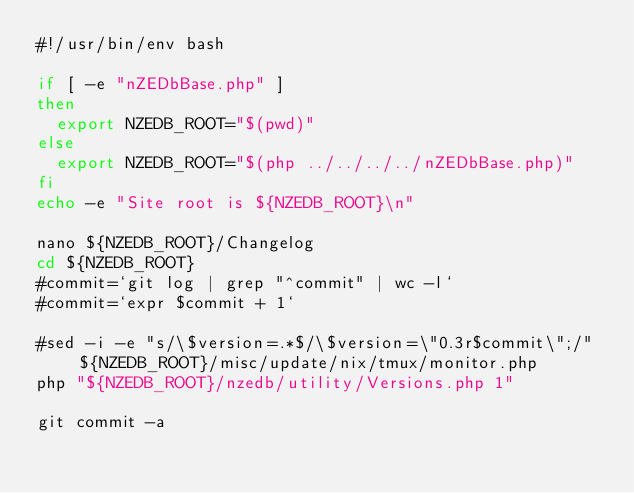<code> <loc_0><loc_0><loc_500><loc_500><_Bash_>#!/usr/bin/env bash

if [ -e "nZEDbBase.php" ]
then
	export NZEDB_ROOT="$(pwd)"
else
	export NZEDB_ROOT="$(php ../../../../nZEDbBase.php)"
fi
echo -e "Site root is ${NZEDB_ROOT}\n"

nano ${NZEDB_ROOT}/Changelog
cd ${NZEDB_ROOT}
#commit=`git log | grep "^commit" | wc -l`
#commit=`expr $commit + 1`

#sed -i -e "s/\$version=.*$/\$version=\"0.3r$commit\";/"  ${NZEDB_ROOT}/misc/update/nix/tmux/monitor.php
php "${NZEDB_ROOT}/nzedb/utility/Versions.php 1"

git commit -a
</code> 